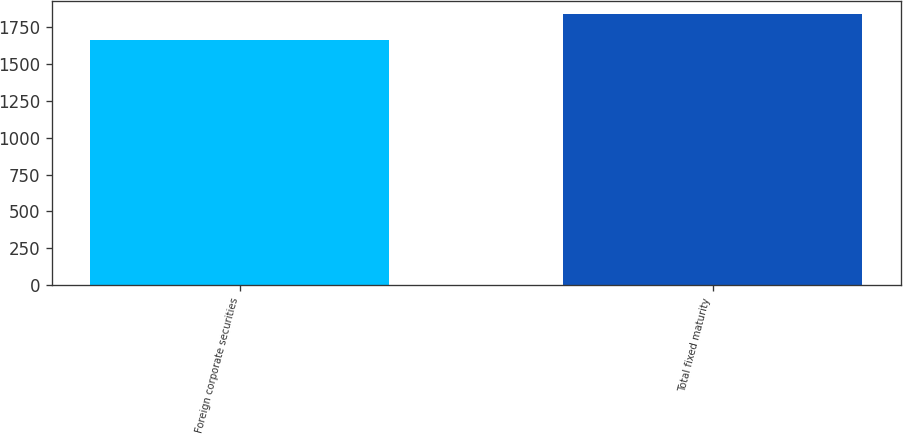Convert chart to OTSL. <chart><loc_0><loc_0><loc_500><loc_500><bar_chart><fcel>Foreign corporate securities<fcel>Total fixed maturity<nl><fcel>1666<fcel>1839<nl></chart> 